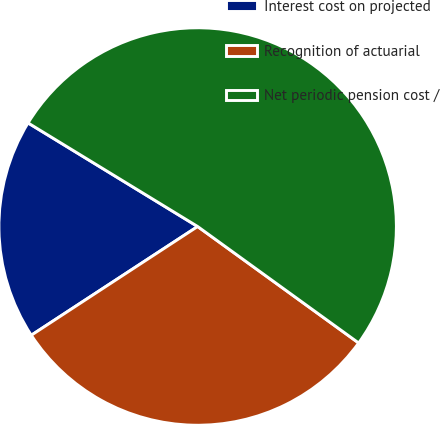Convert chart. <chart><loc_0><loc_0><loc_500><loc_500><pie_chart><fcel>Interest cost on projected<fcel>Recognition of actuarial<fcel>Net periodic pension cost /<nl><fcel>17.94%<fcel>30.82%<fcel>51.24%<nl></chart> 